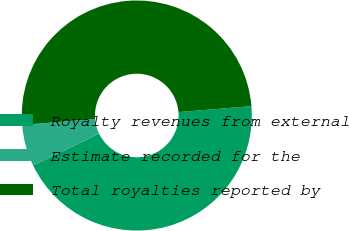Convert chart. <chart><loc_0><loc_0><loc_500><loc_500><pie_chart><fcel>Royalty revenues from external<fcel>Estimate recorded for the<fcel>Total royalties reported by<nl><fcel>44.16%<fcel>5.84%<fcel>50.0%<nl></chart> 